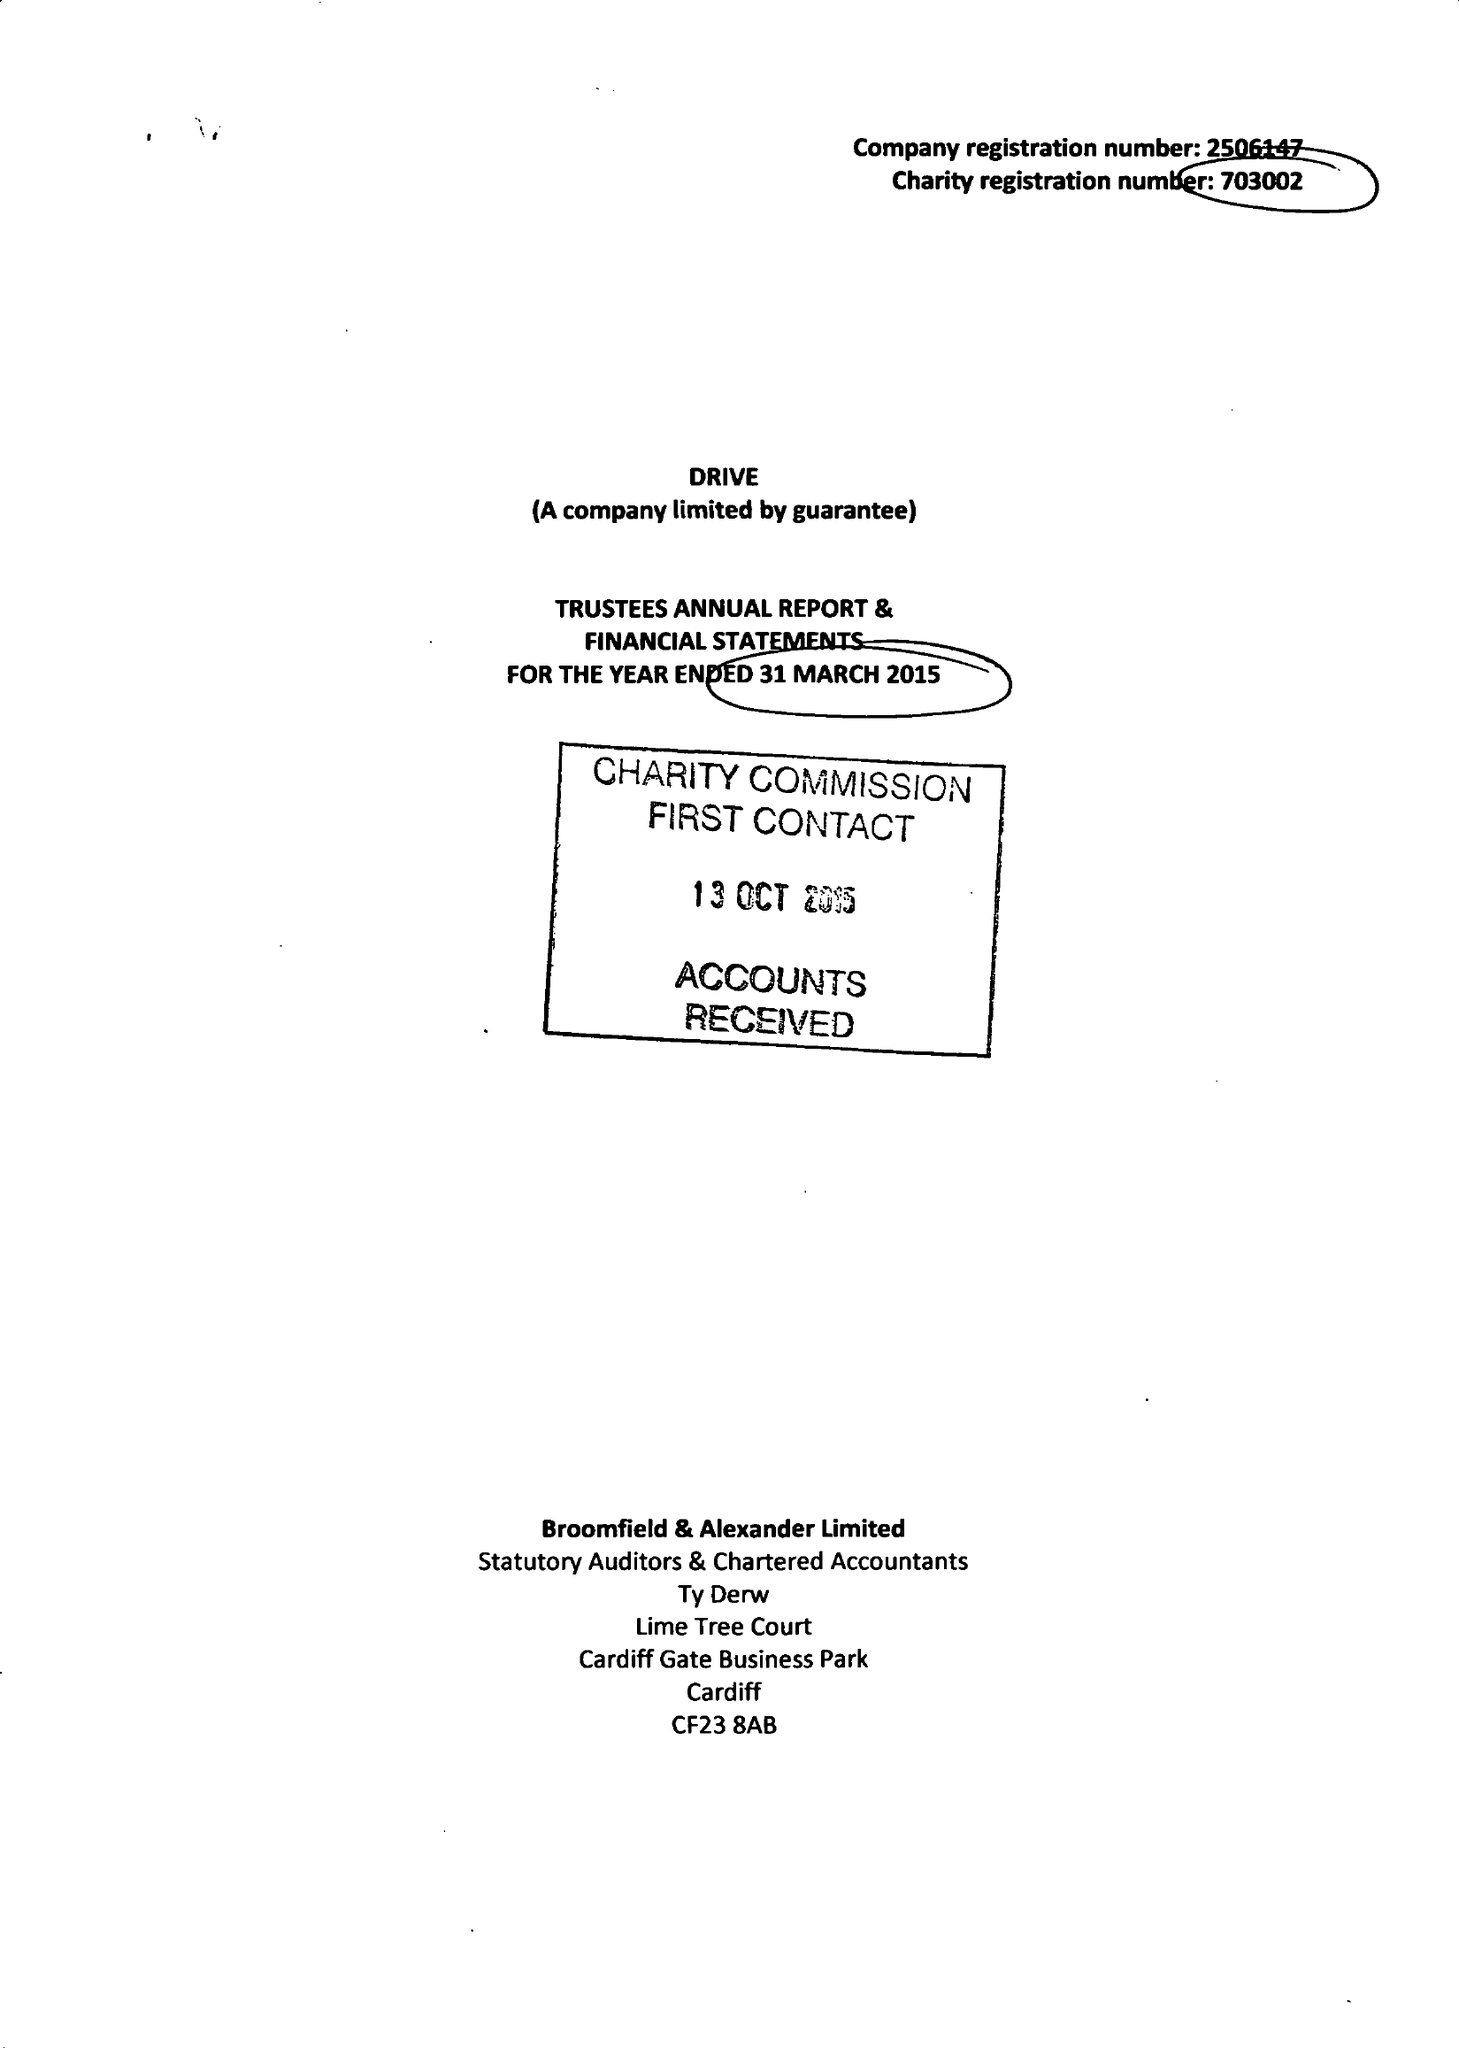What is the value for the charity_number?
Answer the question using a single word or phrase. 703002 